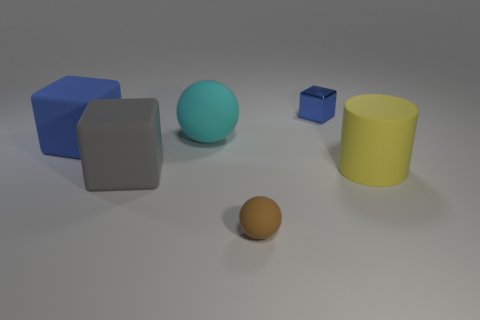How many rubber objects are on the right side of the blue metallic thing and in front of the large gray cube?
Your answer should be very brief. 0. Is there a yellow thing made of the same material as the big sphere?
Offer a very short reply. Yes. There is a matte object that is the same color as the tiny metal cube; what is its size?
Your response must be concise. Large. What number of cubes are either big blue metallic objects or small matte objects?
Give a very brief answer. 0. The yellow cylinder has what size?
Ensure brevity in your answer.  Large. There is a small blue object; how many big cyan rubber things are behind it?
Ensure brevity in your answer.  0. There is a blue object in front of the blue cube that is to the right of the tiny ball; what is its size?
Provide a succinct answer. Large. Does the tiny thing behind the matte cylinder have the same shape as the big rubber object in front of the cylinder?
Provide a short and direct response. Yes. There is a small thing behind the big object right of the tiny sphere; what shape is it?
Give a very brief answer. Cube. There is a matte thing that is both right of the cyan matte sphere and behind the small brown matte ball; what is its size?
Provide a short and direct response. Large. 